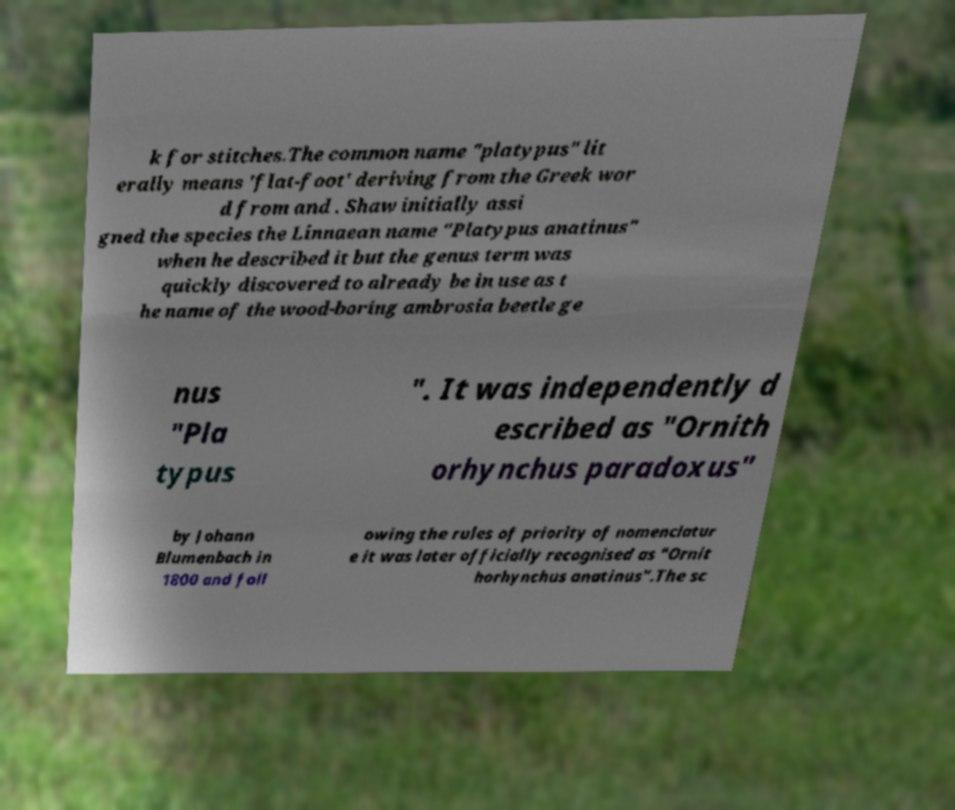Could you extract and type out the text from this image? k for stitches.The common name "platypus" lit erally means 'flat-foot' deriving from the Greek wor d from and . Shaw initially assi gned the species the Linnaean name "Platypus anatinus" when he described it but the genus term was quickly discovered to already be in use as t he name of the wood-boring ambrosia beetle ge nus "Pla typus ". It was independently d escribed as "Ornith orhynchus paradoxus" by Johann Blumenbach in 1800 and foll owing the rules of priority of nomenclatur e it was later officially recognised as "Ornit horhynchus anatinus".The sc 